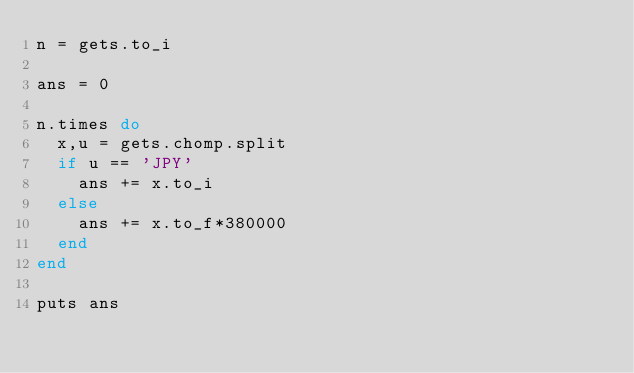Convert code to text. <code><loc_0><loc_0><loc_500><loc_500><_Ruby_>n = gets.to_i

ans = 0

n.times do
  x,u = gets.chomp.split
  if u == 'JPY'
    ans += x.to_i
  else
    ans += x.to_f*380000
  end
end

puts ans</code> 